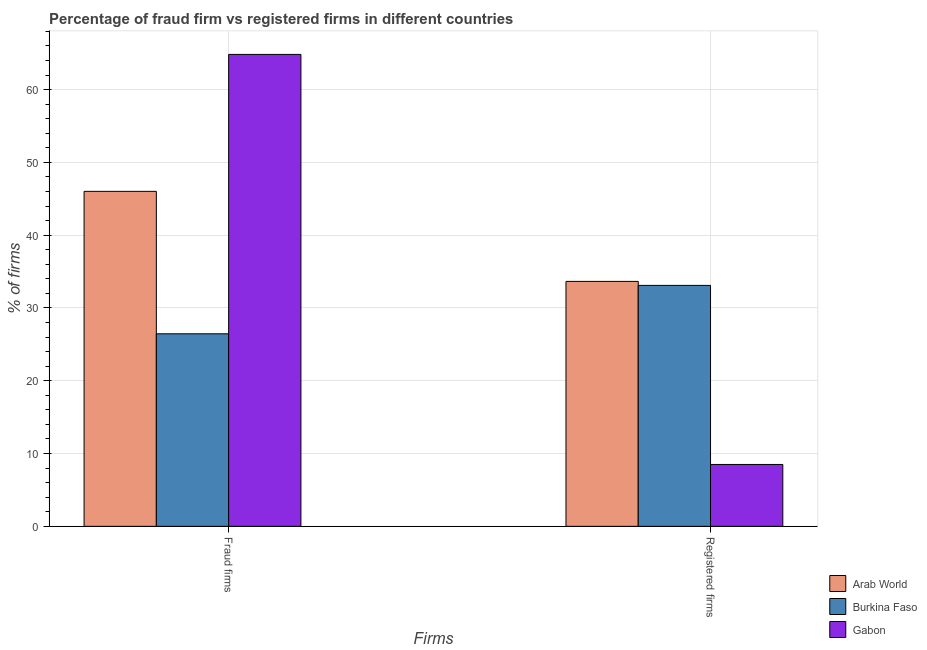Are the number of bars per tick equal to the number of legend labels?
Make the answer very short. Yes. How many bars are there on the 1st tick from the left?
Provide a short and direct response. 3. How many bars are there on the 2nd tick from the right?
Your answer should be very brief. 3. What is the label of the 2nd group of bars from the left?
Provide a short and direct response. Registered firms. What is the percentage of registered firms in Gabon?
Ensure brevity in your answer.  8.5. Across all countries, what is the maximum percentage of registered firms?
Your answer should be compact. 33.65. Across all countries, what is the minimum percentage of fraud firms?
Offer a terse response. 26.45. In which country was the percentage of fraud firms maximum?
Offer a very short reply. Gabon. In which country was the percentage of fraud firms minimum?
Give a very brief answer. Burkina Faso. What is the total percentage of registered firms in the graph?
Offer a terse response. 75.25. What is the difference between the percentage of fraud firms in Gabon and that in Arab World?
Your response must be concise. 18.81. What is the difference between the percentage of fraud firms in Arab World and the percentage of registered firms in Burkina Faso?
Your response must be concise. 12.92. What is the average percentage of registered firms per country?
Offer a very short reply. 25.08. What is the difference between the percentage of fraud firms and percentage of registered firms in Gabon?
Ensure brevity in your answer.  56.33. What is the ratio of the percentage of registered firms in Arab World to that in Burkina Faso?
Your response must be concise. 1.02. What does the 1st bar from the left in Fraud firms represents?
Offer a terse response. Arab World. What does the 3rd bar from the right in Fraud firms represents?
Your answer should be very brief. Arab World. Are all the bars in the graph horizontal?
Your answer should be very brief. No. How many countries are there in the graph?
Your response must be concise. 3. Are the values on the major ticks of Y-axis written in scientific E-notation?
Offer a terse response. No. Does the graph contain grids?
Offer a terse response. Yes. Where does the legend appear in the graph?
Give a very brief answer. Bottom right. How many legend labels are there?
Your answer should be compact. 3. What is the title of the graph?
Offer a terse response. Percentage of fraud firm vs registered firms in different countries. What is the label or title of the X-axis?
Offer a very short reply. Firms. What is the label or title of the Y-axis?
Offer a very short reply. % of firms. What is the % of firms in Arab World in Fraud firms?
Keep it short and to the point. 46.02. What is the % of firms of Burkina Faso in Fraud firms?
Make the answer very short. 26.45. What is the % of firms of Gabon in Fraud firms?
Provide a short and direct response. 64.83. What is the % of firms in Arab World in Registered firms?
Your response must be concise. 33.65. What is the % of firms of Burkina Faso in Registered firms?
Your response must be concise. 33.1. What is the % of firms of Gabon in Registered firms?
Keep it short and to the point. 8.5. Across all Firms, what is the maximum % of firms in Arab World?
Make the answer very short. 46.02. Across all Firms, what is the maximum % of firms in Burkina Faso?
Offer a very short reply. 33.1. Across all Firms, what is the maximum % of firms in Gabon?
Your response must be concise. 64.83. Across all Firms, what is the minimum % of firms in Arab World?
Offer a very short reply. 33.65. Across all Firms, what is the minimum % of firms in Burkina Faso?
Your response must be concise. 26.45. Across all Firms, what is the minimum % of firms in Gabon?
Your answer should be compact. 8.5. What is the total % of firms in Arab World in the graph?
Make the answer very short. 79.67. What is the total % of firms of Burkina Faso in the graph?
Provide a succinct answer. 59.55. What is the total % of firms in Gabon in the graph?
Provide a succinct answer. 73.33. What is the difference between the % of firms of Arab World in Fraud firms and that in Registered firms?
Offer a terse response. 12.37. What is the difference between the % of firms of Burkina Faso in Fraud firms and that in Registered firms?
Ensure brevity in your answer.  -6.65. What is the difference between the % of firms in Gabon in Fraud firms and that in Registered firms?
Provide a succinct answer. 56.33. What is the difference between the % of firms in Arab World in Fraud firms and the % of firms in Burkina Faso in Registered firms?
Ensure brevity in your answer.  12.92. What is the difference between the % of firms of Arab World in Fraud firms and the % of firms of Gabon in Registered firms?
Ensure brevity in your answer.  37.52. What is the difference between the % of firms of Burkina Faso in Fraud firms and the % of firms of Gabon in Registered firms?
Ensure brevity in your answer.  17.95. What is the average % of firms in Arab World per Firms?
Offer a very short reply. 39.84. What is the average % of firms in Burkina Faso per Firms?
Provide a short and direct response. 29.77. What is the average % of firms of Gabon per Firms?
Your answer should be very brief. 36.66. What is the difference between the % of firms of Arab World and % of firms of Burkina Faso in Fraud firms?
Make the answer very short. 19.57. What is the difference between the % of firms of Arab World and % of firms of Gabon in Fraud firms?
Make the answer very short. -18.81. What is the difference between the % of firms of Burkina Faso and % of firms of Gabon in Fraud firms?
Provide a short and direct response. -38.38. What is the difference between the % of firms of Arab World and % of firms of Burkina Faso in Registered firms?
Your answer should be compact. 0.55. What is the difference between the % of firms in Arab World and % of firms in Gabon in Registered firms?
Keep it short and to the point. 25.15. What is the difference between the % of firms in Burkina Faso and % of firms in Gabon in Registered firms?
Your answer should be compact. 24.6. What is the ratio of the % of firms of Arab World in Fraud firms to that in Registered firms?
Ensure brevity in your answer.  1.37. What is the ratio of the % of firms in Burkina Faso in Fraud firms to that in Registered firms?
Keep it short and to the point. 0.8. What is the ratio of the % of firms in Gabon in Fraud firms to that in Registered firms?
Provide a short and direct response. 7.63. What is the difference between the highest and the second highest % of firms of Arab World?
Your answer should be compact. 12.37. What is the difference between the highest and the second highest % of firms in Burkina Faso?
Provide a short and direct response. 6.65. What is the difference between the highest and the second highest % of firms of Gabon?
Ensure brevity in your answer.  56.33. What is the difference between the highest and the lowest % of firms of Arab World?
Ensure brevity in your answer.  12.37. What is the difference between the highest and the lowest % of firms in Burkina Faso?
Your answer should be very brief. 6.65. What is the difference between the highest and the lowest % of firms of Gabon?
Your answer should be very brief. 56.33. 